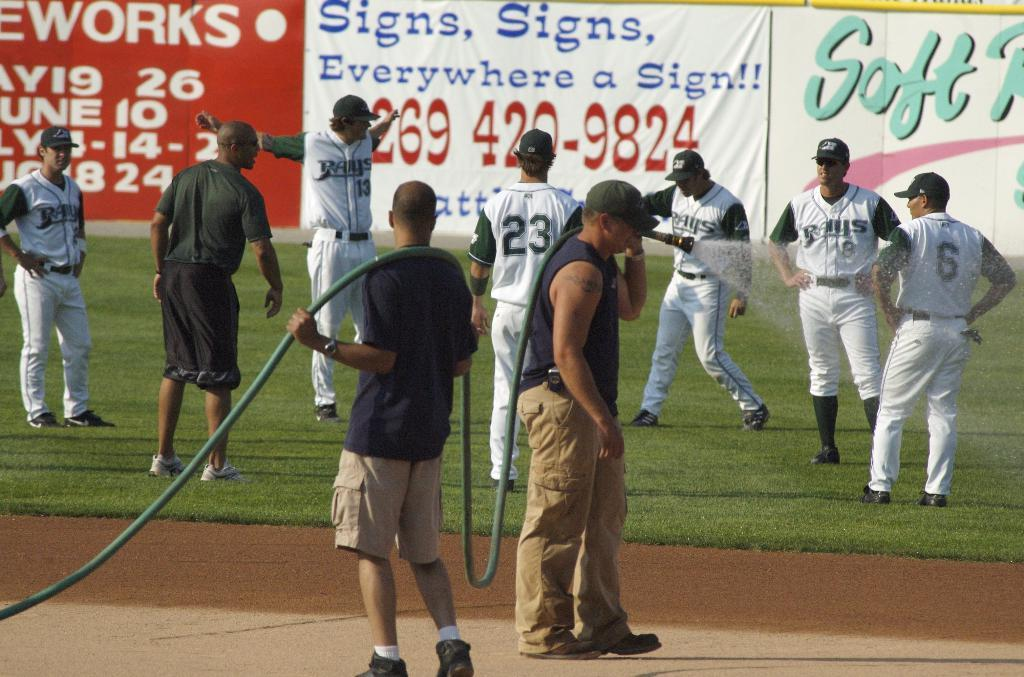<image>
Write a terse but informative summary of the picture. the word soft is on the wall in the background 